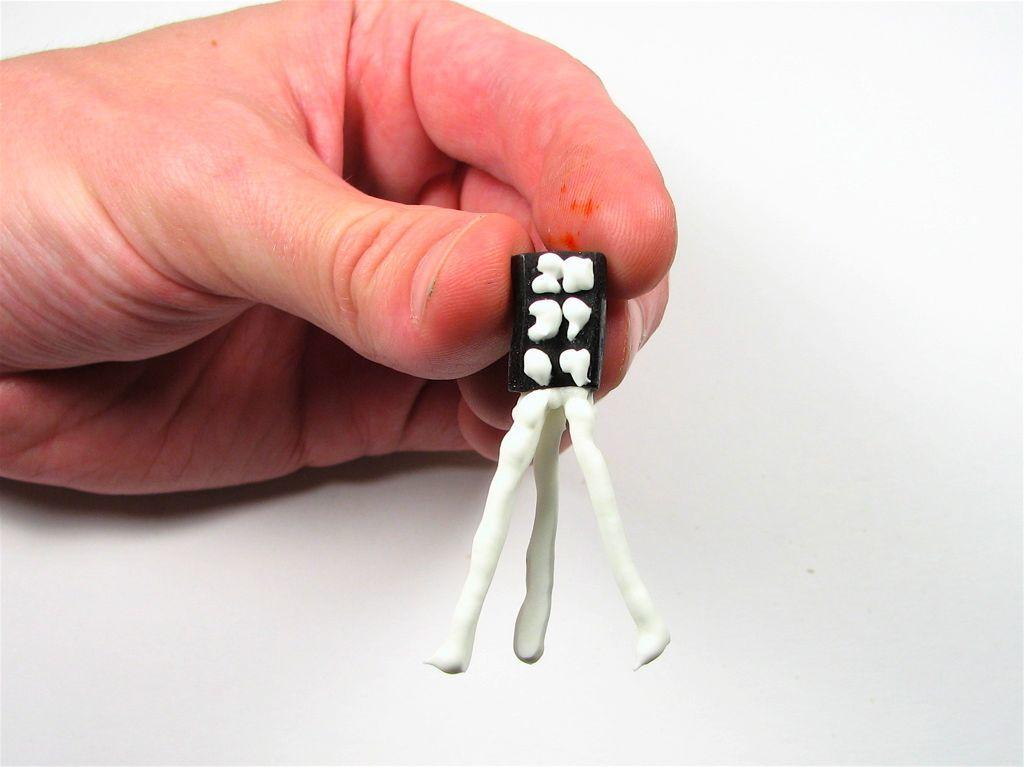What is the person holding in the image? There is a hand of a person holding an object in the image, but the specific object is not mentioned in the facts. What can be seen in the background of the image? The background of the image is white. What type of needle is being used by the person in the image? There is no needle present in the image; only a hand holding an unspecified object is visible. 